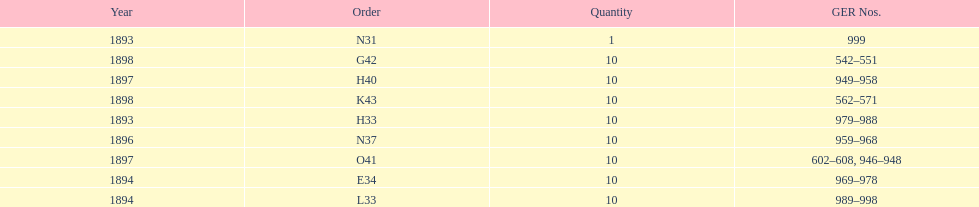Which year had the least ger numbers? 1893. 